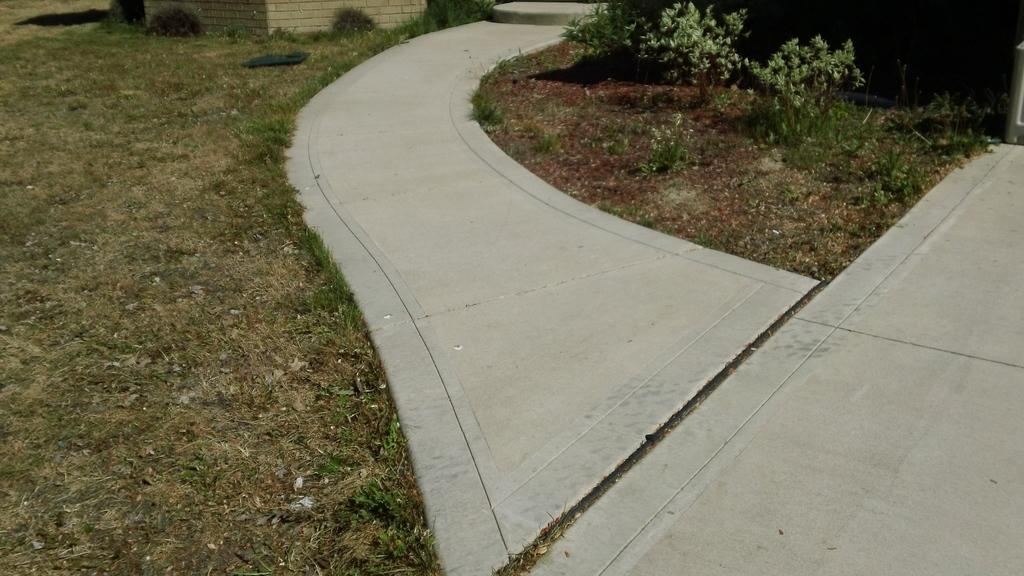What type of vegetation can be seen in the image? There is grass and plants in the image. Can you describe the natural environment depicted in the image? The image features a grassy area with plants. Where is the shop located in the image? There is no shop present in the image. What causes the leaves to fall in the image? There is no indication of leaves falling in the image, as it only features grass and plants. 